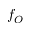Convert formula to latex. <formula><loc_0><loc_0><loc_500><loc_500>f _ { O }</formula> 